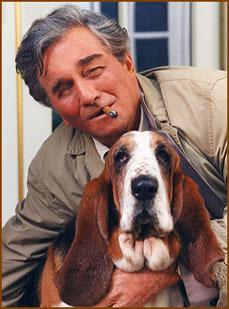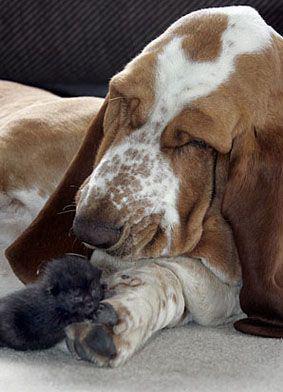The first image is the image on the left, the second image is the image on the right. For the images displayed, is the sentence "At least one image contains a human being." factually correct? Answer yes or no. Yes. The first image is the image on the left, the second image is the image on the right. For the images displayed, is the sentence "There is a droopy dog being held by a person in one image, and a droopy dog with no person in the other." factually correct? Answer yes or no. Yes. 